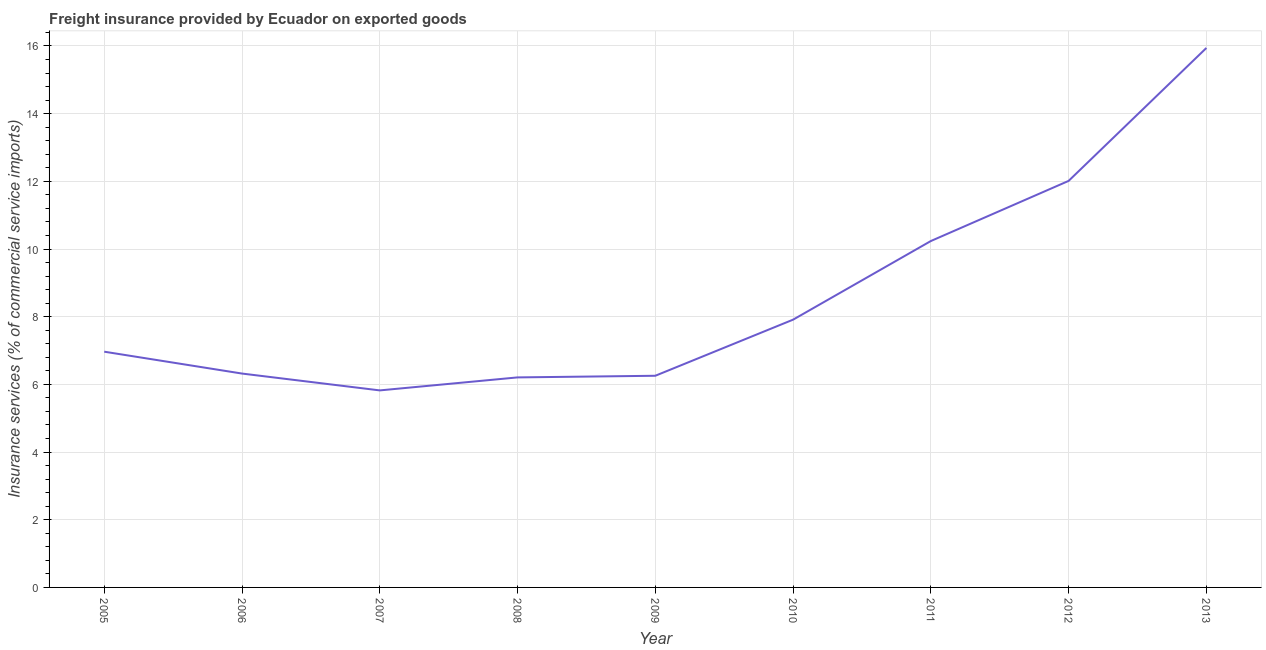What is the freight insurance in 2013?
Your answer should be compact. 15.94. Across all years, what is the maximum freight insurance?
Your response must be concise. 15.94. Across all years, what is the minimum freight insurance?
Ensure brevity in your answer.  5.82. What is the sum of the freight insurance?
Provide a short and direct response. 77.67. What is the difference between the freight insurance in 2008 and 2012?
Your answer should be very brief. -5.81. What is the average freight insurance per year?
Your response must be concise. 8.63. What is the median freight insurance?
Provide a succinct answer. 6.97. What is the ratio of the freight insurance in 2007 to that in 2008?
Your answer should be compact. 0.94. Is the freight insurance in 2007 less than that in 2011?
Your answer should be compact. Yes. Is the difference between the freight insurance in 2005 and 2007 greater than the difference between any two years?
Provide a short and direct response. No. What is the difference between the highest and the second highest freight insurance?
Your answer should be very brief. 3.93. What is the difference between the highest and the lowest freight insurance?
Provide a succinct answer. 10.12. In how many years, is the freight insurance greater than the average freight insurance taken over all years?
Offer a very short reply. 3. Does the freight insurance monotonically increase over the years?
Your answer should be compact. No. How many lines are there?
Make the answer very short. 1. Are the values on the major ticks of Y-axis written in scientific E-notation?
Provide a short and direct response. No. Does the graph contain any zero values?
Provide a short and direct response. No. What is the title of the graph?
Provide a succinct answer. Freight insurance provided by Ecuador on exported goods . What is the label or title of the Y-axis?
Give a very brief answer. Insurance services (% of commercial service imports). What is the Insurance services (% of commercial service imports) in 2005?
Keep it short and to the point. 6.97. What is the Insurance services (% of commercial service imports) of 2006?
Provide a short and direct response. 6.32. What is the Insurance services (% of commercial service imports) of 2007?
Your answer should be very brief. 5.82. What is the Insurance services (% of commercial service imports) in 2008?
Make the answer very short. 6.21. What is the Insurance services (% of commercial service imports) in 2009?
Your answer should be very brief. 6.25. What is the Insurance services (% of commercial service imports) in 2010?
Your response must be concise. 7.91. What is the Insurance services (% of commercial service imports) in 2011?
Make the answer very short. 10.24. What is the Insurance services (% of commercial service imports) in 2012?
Keep it short and to the point. 12.01. What is the Insurance services (% of commercial service imports) in 2013?
Ensure brevity in your answer.  15.94. What is the difference between the Insurance services (% of commercial service imports) in 2005 and 2006?
Offer a terse response. 0.65. What is the difference between the Insurance services (% of commercial service imports) in 2005 and 2007?
Make the answer very short. 1.14. What is the difference between the Insurance services (% of commercial service imports) in 2005 and 2008?
Your response must be concise. 0.76. What is the difference between the Insurance services (% of commercial service imports) in 2005 and 2009?
Keep it short and to the point. 0.71. What is the difference between the Insurance services (% of commercial service imports) in 2005 and 2010?
Your answer should be compact. -0.95. What is the difference between the Insurance services (% of commercial service imports) in 2005 and 2011?
Your answer should be compact. -3.27. What is the difference between the Insurance services (% of commercial service imports) in 2005 and 2012?
Your answer should be compact. -5.05. What is the difference between the Insurance services (% of commercial service imports) in 2005 and 2013?
Your answer should be compact. -8.98. What is the difference between the Insurance services (% of commercial service imports) in 2006 and 2007?
Provide a succinct answer. 0.5. What is the difference between the Insurance services (% of commercial service imports) in 2006 and 2008?
Provide a succinct answer. 0.11. What is the difference between the Insurance services (% of commercial service imports) in 2006 and 2009?
Keep it short and to the point. 0.07. What is the difference between the Insurance services (% of commercial service imports) in 2006 and 2010?
Your response must be concise. -1.59. What is the difference between the Insurance services (% of commercial service imports) in 2006 and 2011?
Keep it short and to the point. -3.92. What is the difference between the Insurance services (% of commercial service imports) in 2006 and 2012?
Keep it short and to the point. -5.69. What is the difference between the Insurance services (% of commercial service imports) in 2006 and 2013?
Your response must be concise. -9.62. What is the difference between the Insurance services (% of commercial service imports) in 2007 and 2008?
Provide a succinct answer. -0.38. What is the difference between the Insurance services (% of commercial service imports) in 2007 and 2009?
Your answer should be very brief. -0.43. What is the difference between the Insurance services (% of commercial service imports) in 2007 and 2010?
Your answer should be compact. -2.09. What is the difference between the Insurance services (% of commercial service imports) in 2007 and 2011?
Give a very brief answer. -4.41. What is the difference between the Insurance services (% of commercial service imports) in 2007 and 2012?
Make the answer very short. -6.19. What is the difference between the Insurance services (% of commercial service imports) in 2007 and 2013?
Keep it short and to the point. -10.12. What is the difference between the Insurance services (% of commercial service imports) in 2008 and 2009?
Keep it short and to the point. -0.05. What is the difference between the Insurance services (% of commercial service imports) in 2008 and 2010?
Give a very brief answer. -1.71. What is the difference between the Insurance services (% of commercial service imports) in 2008 and 2011?
Keep it short and to the point. -4.03. What is the difference between the Insurance services (% of commercial service imports) in 2008 and 2012?
Your answer should be compact. -5.81. What is the difference between the Insurance services (% of commercial service imports) in 2008 and 2013?
Ensure brevity in your answer.  -9.74. What is the difference between the Insurance services (% of commercial service imports) in 2009 and 2010?
Make the answer very short. -1.66. What is the difference between the Insurance services (% of commercial service imports) in 2009 and 2011?
Provide a succinct answer. -3.98. What is the difference between the Insurance services (% of commercial service imports) in 2009 and 2012?
Your answer should be very brief. -5.76. What is the difference between the Insurance services (% of commercial service imports) in 2009 and 2013?
Offer a terse response. -9.69. What is the difference between the Insurance services (% of commercial service imports) in 2010 and 2011?
Your answer should be compact. -2.32. What is the difference between the Insurance services (% of commercial service imports) in 2010 and 2012?
Your answer should be very brief. -4.1. What is the difference between the Insurance services (% of commercial service imports) in 2010 and 2013?
Make the answer very short. -8.03. What is the difference between the Insurance services (% of commercial service imports) in 2011 and 2012?
Your answer should be compact. -1.78. What is the difference between the Insurance services (% of commercial service imports) in 2011 and 2013?
Provide a short and direct response. -5.71. What is the difference between the Insurance services (% of commercial service imports) in 2012 and 2013?
Ensure brevity in your answer.  -3.93. What is the ratio of the Insurance services (% of commercial service imports) in 2005 to that in 2006?
Your answer should be very brief. 1.1. What is the ratio of the Insurance services (% of commercial service imports) in 2005 to that in 2007?
Provide a short and direct response. 1.2. What is the ratio of the Insurance services (% of commercial service imports) in 2005 to that in 2008?
Ensure brevity in your answer.  1.12. What is the ratio of the Insurance services (% of commercial service imports) in 2005 to that in 2009?
Offer a very short reply. 1.11. What is the ratio of the Insurance services (% of commercial service imports) in 2005 to that in 2010?
Ensure brevity in your answer.  0.88. What is the ratio of the Insurance services (% of commercial service imports) in 2005 to that in 2011?
Make the answer very short. 0.68. What is the ratio of the Insurance services (% of commercial service imports) in 2005 to that in 2012?
Your response must be concise. 0.58. What is the ratio of the Insurance services (% of commercial service imports) in 2005 to that in 2013?
Keep it short and to the point. 0.44. What is the ratio of the Insurance services (% of commercial service imports) in 2006 to that in 2007?
Ensure brevity in your answer.  1.08. What is the ratio of the Insurance services (% of commercial service imports) in 2006 to that in 2008?
Make the answer very short. 1.02. What is the ratio of the Insurance services (% of commercial service imports) in 2006 to that in 2010?
Offer a terse response. 0.8. What is the ratio of the Insurance services (% of commercial service imports) in 2006 to that in 2011?
Give a very brief answer. 0.62. What is the ratio of the Insurance services (% of commercial service imports) in 2006 to that in 2012?
Make the answer very short. 0.53. What is the ratio of the Insurance services (% of commercial service imports) in 2006 to that in 2013?
Offer a terse response. 0.4. What is the ratio of the Insurance services (% of commercial service imports) in 2007 to that in 2008?
Give a very brief answer. 0.94. What is the ratio of the Insurance services (% of commercial service imports) in 2007 to that in 2010?
Keep it short and to the point. 0.74. What is the ratio of the Insurance services (% of commercial service imports) in 2007 to that in 2011?
Keep it short and to the point. 0.57. What is the ratio of the Insurance services (% of commercial service imports) in 2007 to that in 2012?
Ensure brevity in your answer.  0.48. What is the ratio of the Insurance services (% of commercial service imports) in 2007 to that in 2013?
Ensure brevity in your answer.  0.36. What is the ratio of the Insurance services (% of commercial service imports) in 2008 to that in 2009?
Your response must be concise. 0.99. What is the ratio of the Insurance services (% of commercial service imports) in 2008 to that in 2010?
Ensure brevity in your answer.  0.78. What is the ratio of the Insurance services (% of commercial service imports) in 2008 to that in 2011?
Keep it short and to the point. 0.61. What is the ratio of the Insurance services (% of commercial service imports) in 2008 to that in 2012?
Your answer should be compact. 0.52. What is the ratio of the Insurance services (% of commercial service imports) in 2008 to that in 2013?
Keep it short and to the point. 0.39. What is the ratio of the Insurance services (% of commercial service imports) in 2009 to that in 2010?
Your answer should be compact. 0.79. What is the ratio of the Insurance services (% of commercial service imports) in 2009 to that in 2011?
Provide a succinct answer. 0.61. What is the ratio of the Insurance services (% of commercial service imports) in 2009 to that in 2012?
Ensure brevity in your answer.  0.52. What is the ratio of the Insurance services (% of commercial service imports) in 2009 to that in 2013?
Provide a short and direct response. 0.39. What is the ratio of the Insurance services (% of commercial service imports) in 2010 to that in 2011?
Provide a short and direct response. 0.77. What is the ratio of the Insurance services (% of commercial service imports) in 2010 to that in 2012?
Your response must be concise. 0.66. What is the ratio of the Insurance services (% of commercial service imports) in 2010 to that in 2013?
Offer a terse response. 0.5. What is the ratio of the Insurance services (% of commercial service imports) in 2011 to that in 2012?
Your response must be concise. 0.85. What is the ratio of the Insurance services (% of commercial service imports) in 2011 to that in 2013?
Offer a terse response. 0.64. What is the ratio of the Insurance services (% of commercial service imports) in 2012 to that in 2013?
Keep it short and to the point. 0.75. 